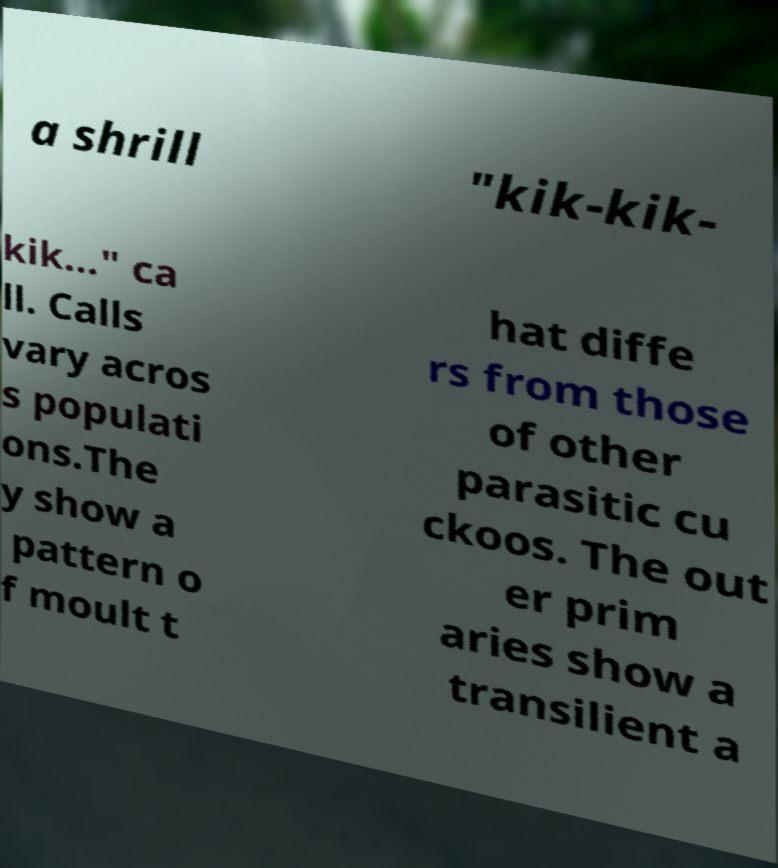Please identify and transcribe the text found in this image. a shrill "kik-kik- kik..." ca ll. Calls vary acros s populati ons.The y show a pattern o f moult t hat diffe rs from those of other parasitic cu ckoos. The out er prim aries show a transilient a 